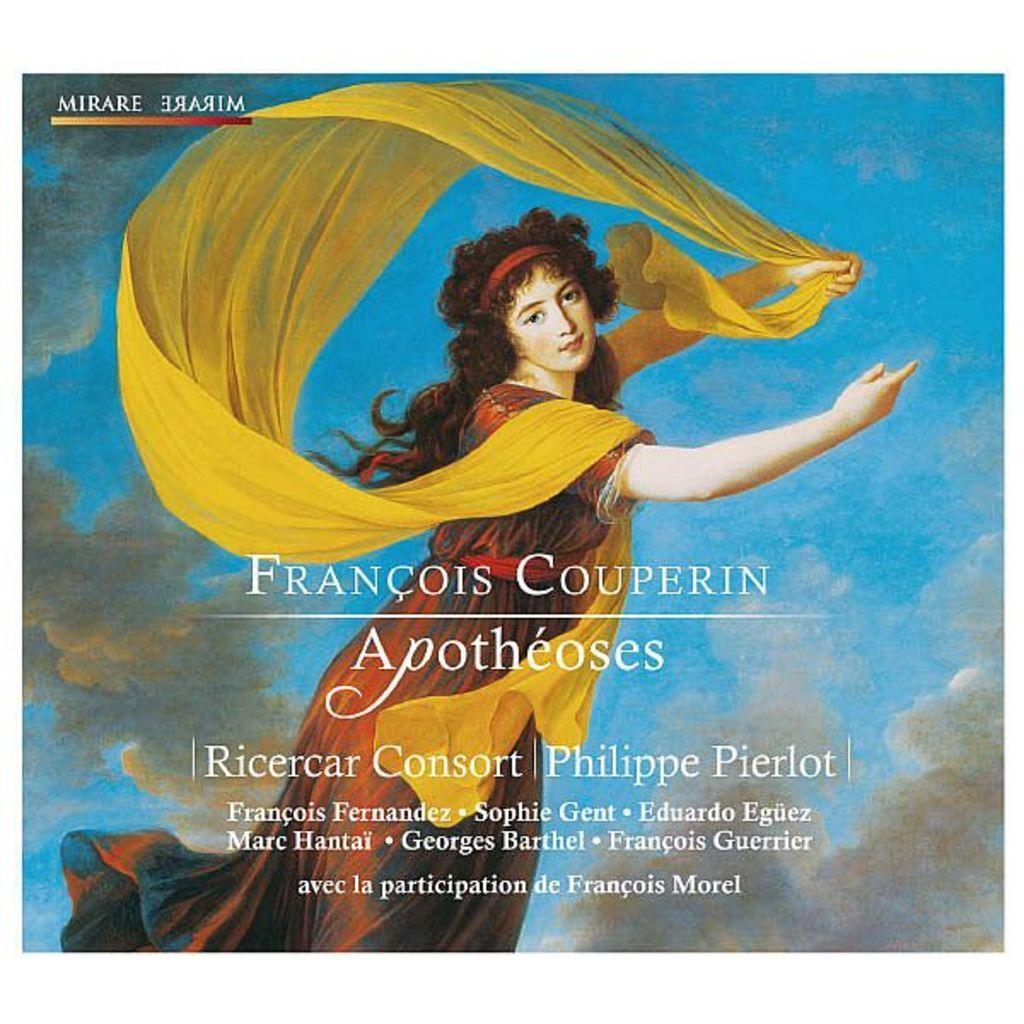<image>
Provide a brief description of the given image. An album cover for Francois Couperin Apotheoses with a woman on it. 